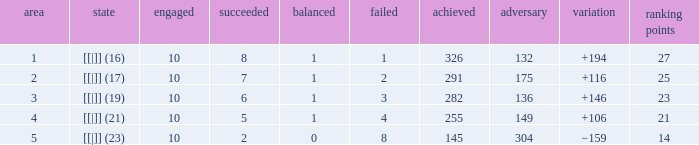 How many games had a deficit of 175?  1.0. 